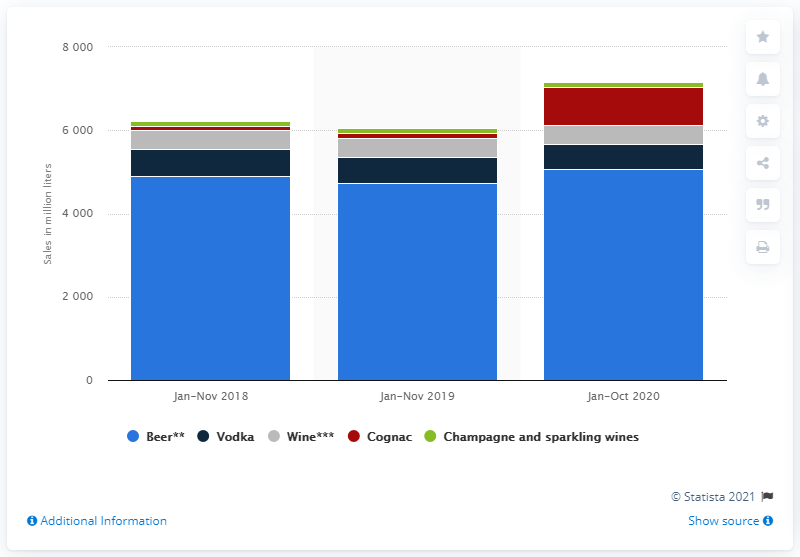Identify some key points in this picture. In the period of January to October 2020, a total of 920.87 liters of cognac were sold. 